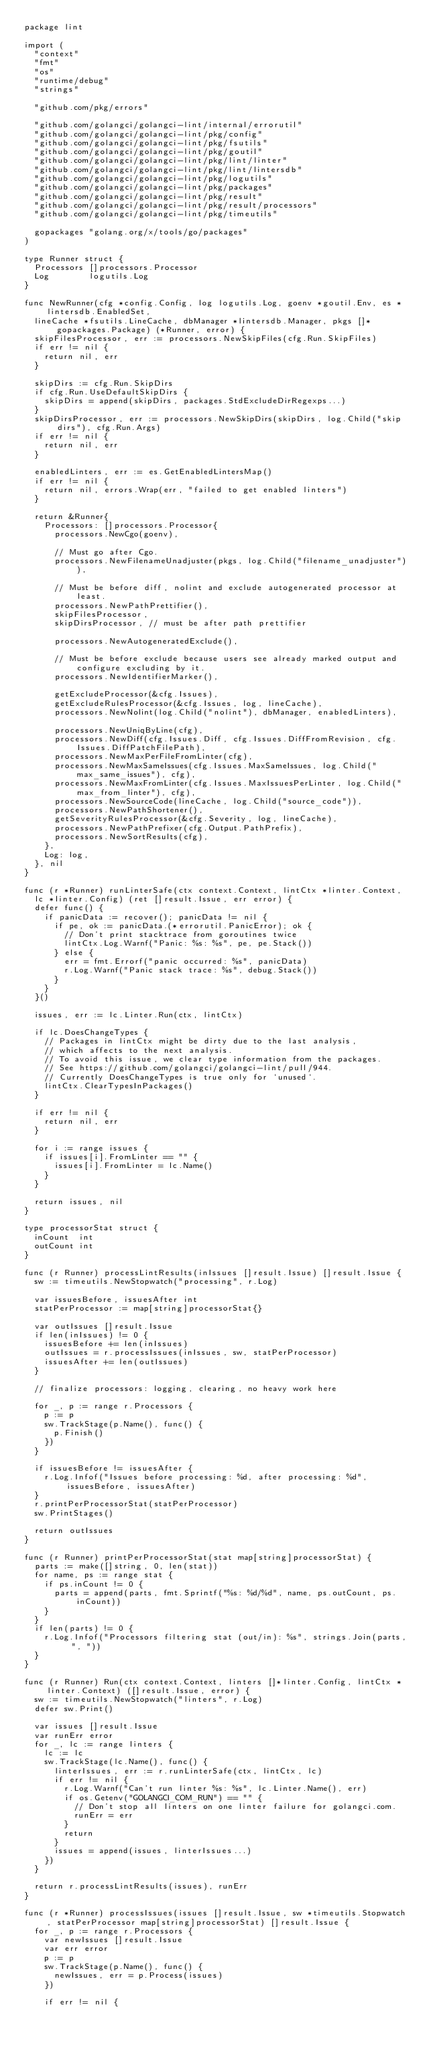Convert code to text. <code><loc_0><loc_0><loc_500><loc_500><_Go_>package lint

import (
	"context"
	"fmt"
	"os"
	"runtime/debug"
	"strings"

	"github.com/pkg/errors"

	"github.com/golangci/golangci-lint/internal/errorutil"
	"github.com/golangci/golangci-lint/pkg/config"
	"github.com/golangci/golangci-lint/pkg/fsutils"
	"github.com/golangci/golangci-lint/pkg/goutil"
	"github.com/golangci/golangci-lint/pkg/lint/linter"
	"github.com/golangci/golangci-lint/pkg/lint/lintersdb"
	"github.com/golangci/golangci-lint/pkg/logutils"
	"github.com/golangci/golangci-lint/pkg/packages"
	"github.com/golangci/golangci-lint/pkg/result"
	"github.com/golangci/golangci-lint/pkg/result/processors"
	"github.com/golangci/golangci-lint/pkg/timeutils"

	gopackages "golang.org/x/tools/go/packages"
)

type Runner struct {
	Processors []processors.Processor
	Log        logutils.Log
}

func NewRunner(cfg *config.Config, log logutils.Log, goenv *goutil.Env, es *lintersdb.EnabledSet,
	lineCache *fsutils.LineCache, dbManager *lintersdb.Manager, pkgs []*gopackages.Package) (*Runner, error) {
	skipFilesProcessor, err := processors.NewSkipFiles(cfg.Run.SkipFiles)
	if err != nil {
		return nil, err
	}

	skipDirs := cfg.Run.SkipDirs
	if cfg.Run.UseDefaultSkipDirs {
		skipDirs = append(skipDirs, packages.StdExcludeDirRegexps...)
	}
	skipDirsProcessor, err := processors.NewSkipDirs(skipDirs, log.Child("skip dirs"), cfg.Run.Args)
	if err != nil {
		return nil, err
	}

	enabledLinters, err := es.GetEnabledLintersMap()
	if err != nil {
		return nil, errors.Wrap(err, "failed to get enabled linters")
	}

	return &Runner{
		Processors: []processors.Processor{
			processors.NewCgo(goenv),

			// Must go after Cgo.
			processors.NewFilenameUnadjuster(pkgs, log.Child("filename_unadjuster")),

			// Must be before diff, nolint and exclude autogenerated processor at least.
			processors.NewPathPrettifier(),
			skipFilesProcessor,
			skipDirsProcessor, // must be after path prettifier

			processors.NewAutogeneratedExclude(),

			// Must be before exclude because users see already marked output and configure excluding by it.
			processors.NewIdentifierMarker(),

			getExcludeProcessor(&cfg.Issues),
			getExcludeRulesProcessor(&cfg.Issues, log, lineCache),
			processors.NewNolint(log.Child("nolint"), dbManager, enabledLinters),

			processors.NewUniqByLine(cfg),
			processors.NewDiff(cfg.Issues.Diff, cfg.Issues.DiffFromRevision, cfg.Issues.DiffPatchFilePath),
			processors.NewMaxPerFileFromLinter(cfg),
			processors.NewMaxSameIssues(cfg.Issues.MaxSameIssues, log.Child("max_same_issues"), cfg),
			processors.NewMaxFromLinter(cfg.Issues.MaxIssuesPerLinter, log.Child("max_from_linter"), cfg),
			processors.NewSourceCode(lineCache, log.Child("source_code")),
			processors.NewPathShortener(),
			getSeverityRulesProcessor(&cfg.Severity, log, lineCache),
			processors.NewPathPrefixer(cfg.Output.PathPrefix),
			processors.NewSortResults(cfg),
		},
		Log: log,
	}, nil
}

func (r *Runner) runLinterSafe(ctx context.Context, lintCtx *linter.Context,
	lc *linter.Config) (ret []result.Issue, err error) {
	defer func() {
		if panicData := recover(); panicData != nil {
			if pe, ok := panicData.(*errorutil.PanicError); ok {
				// Don't print stacktrace from goroutines twice
				lintCtx.Log.Warnf("Panic: %s: %s", pe, pe.Stack())
			} else {
				err = fmt.Errorf("panic occurred: %s", panicData)
				r.Log.Warnf("Panic stack trace: %s", debug.Stack())
			}
		}
	}()

	issues, err := lc.Linter.Run(ctx, lintCtx)

	if lc.DoesChangeTypes {
		// Packages in lintCtx might be dirty due to the last analysis,
		// which affects to the next analysis.
		// To avoid this issue, we clear type information from the packages.
		// See https://github.com/golangci/golangci-lint/pull/944.
		// Currently DoesChangeTypes is true only for `unused`.
		lintCtx.ClearTypesInPackages()
	}

	if err != nil {
		return nil, err
	}

	for i := range issues {
		if issues[i].FromLinter == "" {
			issues[i].FromLinter = lc.Name()
		}
	}

	return issues, nil
}

type processorStat struct {
	inCount  int
	outCount int
}

func (r Runner) processLintResults(inIssues []result.Issue) []result.Issue {
	sw := timeutils.NewStopwatch("processing", r.Log)

	var issuesBefore, issuesAfter int
	statPerProcessor := map[string]processorStat{}

	var outIssues []result.Issue
	if len(inIssues) != 0 {
		issuesBefore += len(inIssues)
		outIssues = r.processIssues(inIssues, sw, statPerProcessor)
		issuesAfter += len(outIssues)
	}

	// finalize processors: logging, clearing, no heavy work here

	for _, p := range r.Processors {
		p := p
		sw.TrackStage(p.Name(), func() {
			p.Finish()
		})
	}

	if issuesBefore != issuesAfter {
		r.Log.Infof("Issues before processing: %d, after processing: %d", issuesBefore, issuesAfter)
	}
	r.printPerProcessorStat(statPerProcessor)
	sw.PrintStages()

	return outIssues
}

func (r Runner) printPerProcessorStat(stat map[string]processorStat) {
	parts := make([]string, 0, len(stat))
	for name, ps := range stat {
		if ps.inCount != 0 {
			parts = append(parts, fmt.Sprintf("%s: %d/%d", name, ps.outCount, ps.inCount))
		}
	}
	if len(parts) != 0 {
		r.Log.Infof("Processors filtering stat (out/in): %s", strings.Join(parts, ", "))
	}
}

func (r Runner) Run(ctx context.Context, linters []*linter.Config, lintCtx *linter.Context) ([]result.Issue, error) {
	sw := timeutils.NewStopwatch("linters", r.Log)
	defer sw.Print()

	var issues []result.Issue
	var runErr error
	for _, lc := range linters {
		lc := lc
		sw.TrackStage(lc.Name(), func() {
			linterIssues, err := r.runLinterSafe(ctx, lintCtx, lc)
			if err != nil {
				r.Log.Warnf("Can't run linter %s: %s", lc.Linter.Name(), err)
				if os.Getenv("GOLANGCI_COM_RUN") == "" {
					// Don't stop all linters on one linter failure for golangci.com.
					runErr = err
				}
				return
			}
			issues = append(issues, linterIssues...)
		})
	}

	return r.processLintResults(issues), runErr
}

func (r *Runner) processIssues(issues []result.Issue, sw *timeutils.Stopwatch, statPerProcessor map[string]processorStat) []result.Issue {
	for _, p := range r.Processors {
		var newIssues []result.Issue
		var err error
		p := p
		sw.TrackStage(p.Name(), func() {
			newIssues, err = p.Process(issues)
		})

		if err != nil {</code> 